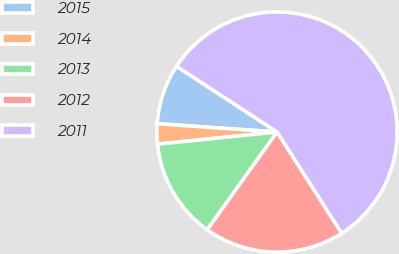<chart> <loc_0><loc_0><loc_500><loc_500><pie_chart><fcel>2015<fcel>2014<fcel>2013<fcel>2012<fcel>2011<nl><fcel>8.12%<fcel>2.71%<fcel>13.52%<fcel>18.92%<fcel>56.73%<nl></chart> 